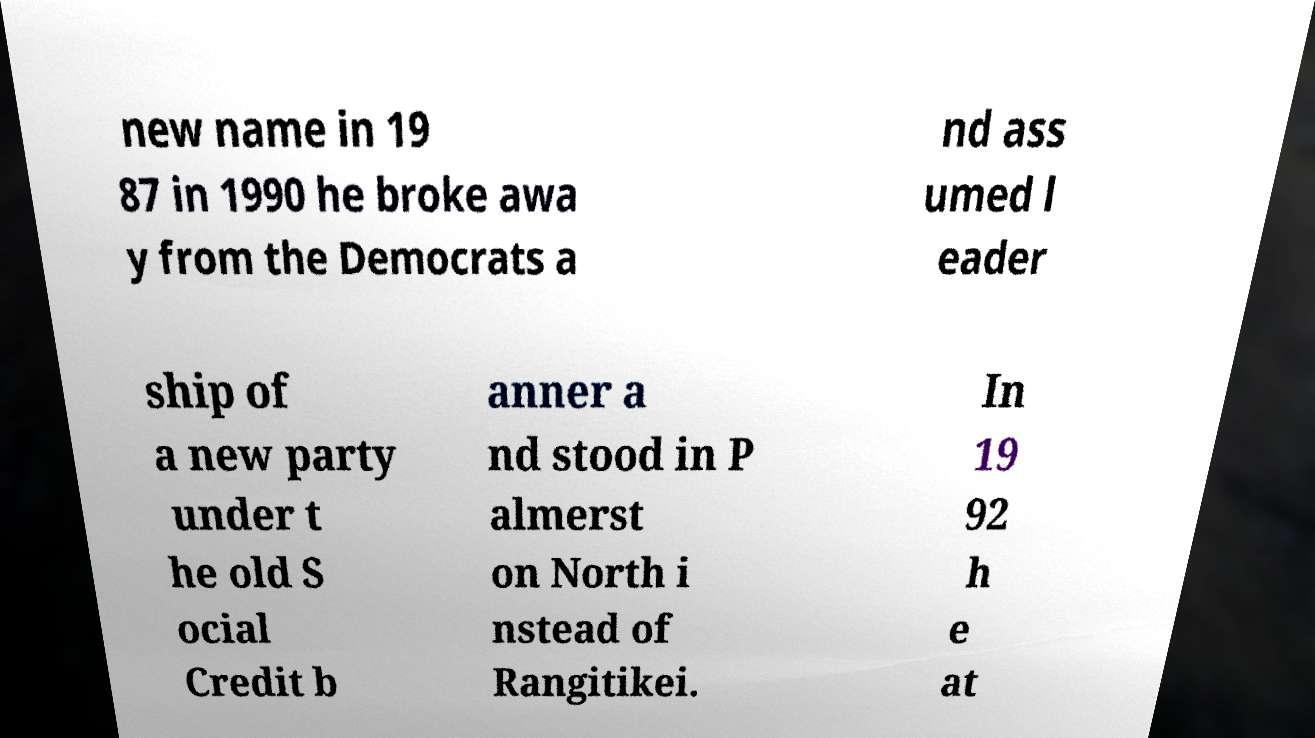There's text embedded in this image that I need extracted. Can you transcribe it verbatim? new name in 19 87 in 1990 he broke awa y from the Democrats a nd ass umed l eader ship of a new party under t he old S ocial Credit b anner a nd stood in P almerst on North i nstead of Rangitikei. In 19 92 h e at 